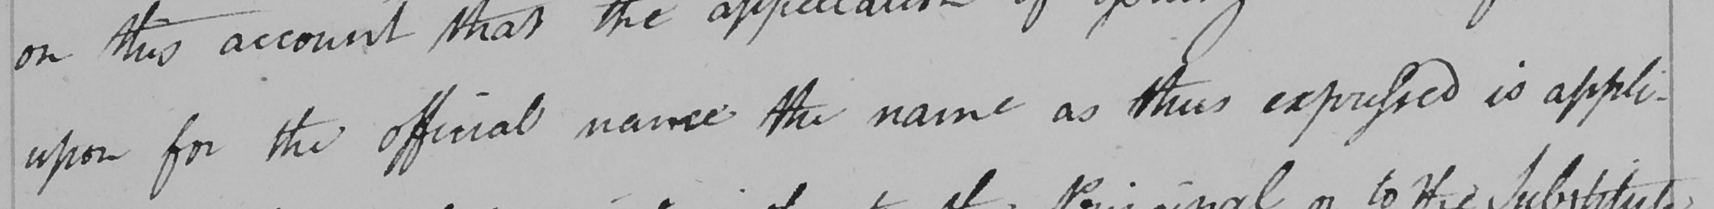Transcribe the text shown in this historical manuscript line. upon for the official name the name as thus expressed is appli- 